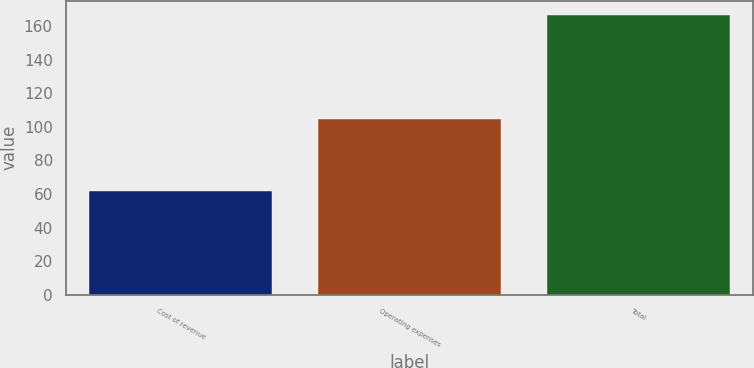<chart> <loc_0><loc_0><loc_500><loc_500><bar_chart><fcel>Cost of revenue<fcel>Operating expenses<fcel>Total<nl><fcel>62<fcel>104.9<fcel>166.9<nl></chart> 